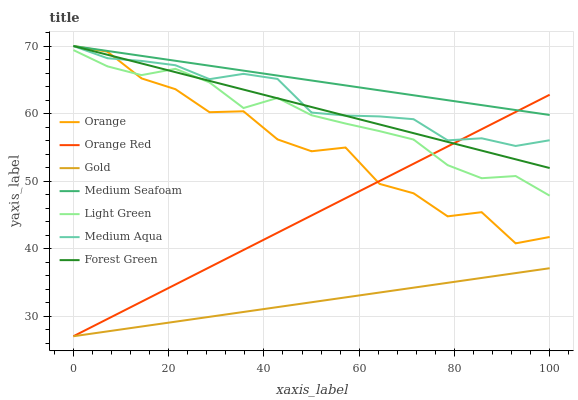Does Gold have the minimum area under the curve?
Answer yes or no. Yes. Does Medium Seafoam have the maximum area under the curve?
Answer yes or no. Yes. Does Forest Green have the minimum area under the curve?
Answer yes or no. No. Does Forest Green have the maximum area under the curve?
Answer yes or no. No. Is Gold the smoothest?
Answer yes or no. Yes. Is Orange the roughest?
Answer yes or no. Yes. Is Medium Seafoam the smoothest?
Answer yes or no. No. Is Medium Seafoam the roughest?
Answer yes or no. No. Does Gold have the lowest value?
Answer yes or no. Yes. Does Forest Green have the lowest value?
Answer yes or no. No. Does Orange have the highest value?
Answer yes or no. Yes. Does Light Green have the highest value?
Answer yes or no. No. Is Light Green less than Medium Aqua?
Answer yes or no. Yes. Is Medium Aqua greater than Gold?
Answer yes or no. Yes. Does Orange intersect Medium Aqua?
Answer yes or no. Yes. Is Orange less than Medium Aqua?
Answer yes or no. No. Is Orange greater than Medium Aqua?
Answer yes or no. No. Does Light Green intersect Medium Aqua?
Answer yes or no. No. 